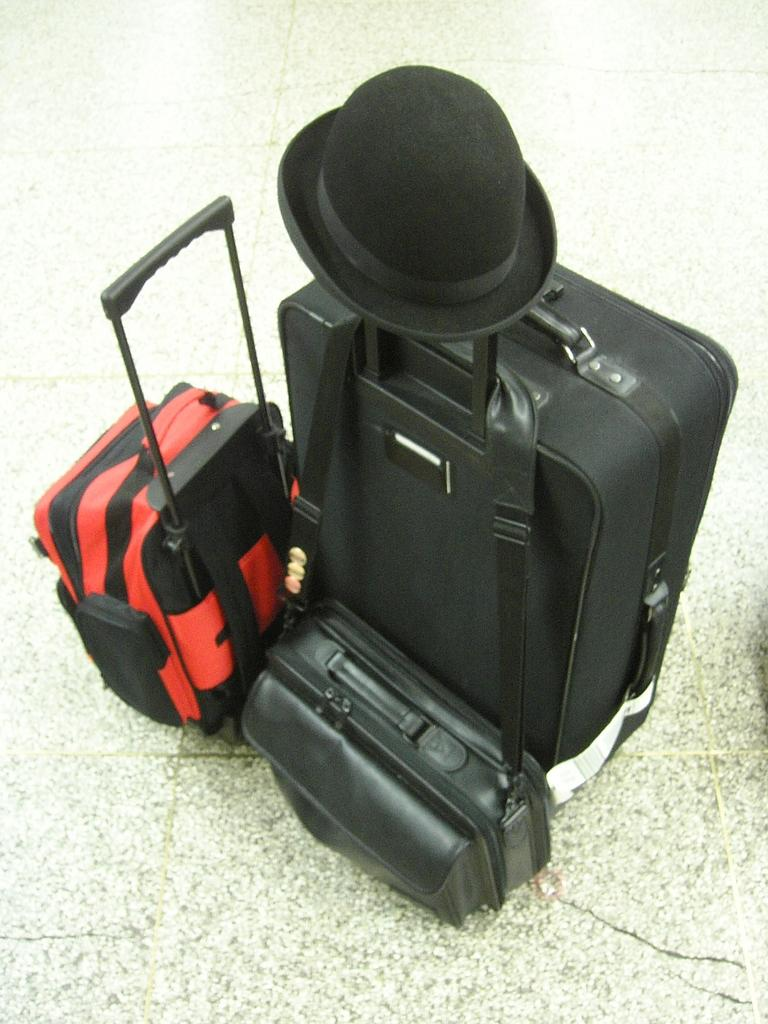What type of bags are on the floor in the image? There are luggage bags and a handbag on the floor in the image. What is placed on one of the luggage bags? A cap is placed on one of the luggage bags. How many children are playing with the luggage bags in the image? There are no children present in the image; it only shows luggage bags, a handbag, and a cap. What type of currency exchange is taking place in the image? There is no currency exchange or any financial transaction depicted in the image. 